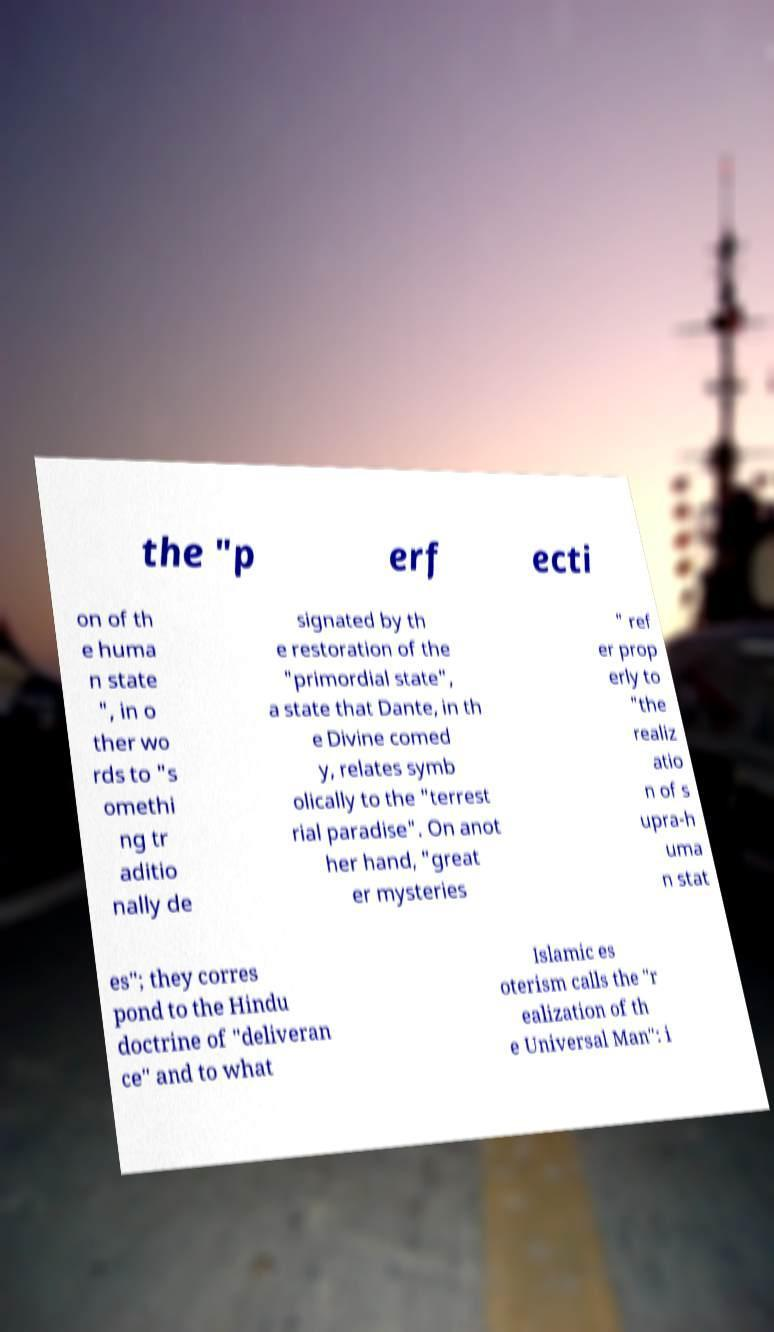Could you extract and type out the text from this image? the "p erf ecti on of th e huma n state ", in o ther wo rds to "s omethi ng tr aditio nally de signated by th e restoration of the "primordial state", a state that Dante, in th e Divine comed y, relates symb olically to the "terrest rial paradise". On anot her hand, "great er mysteries " ref er prop erly to "the realiz atio n of s upra-h uma n stat es"; they corres pond to the Hindu doctrine of "deliveran ce" and to what Islamic es oterism calls the "r ealization of th e Universal Man": i 